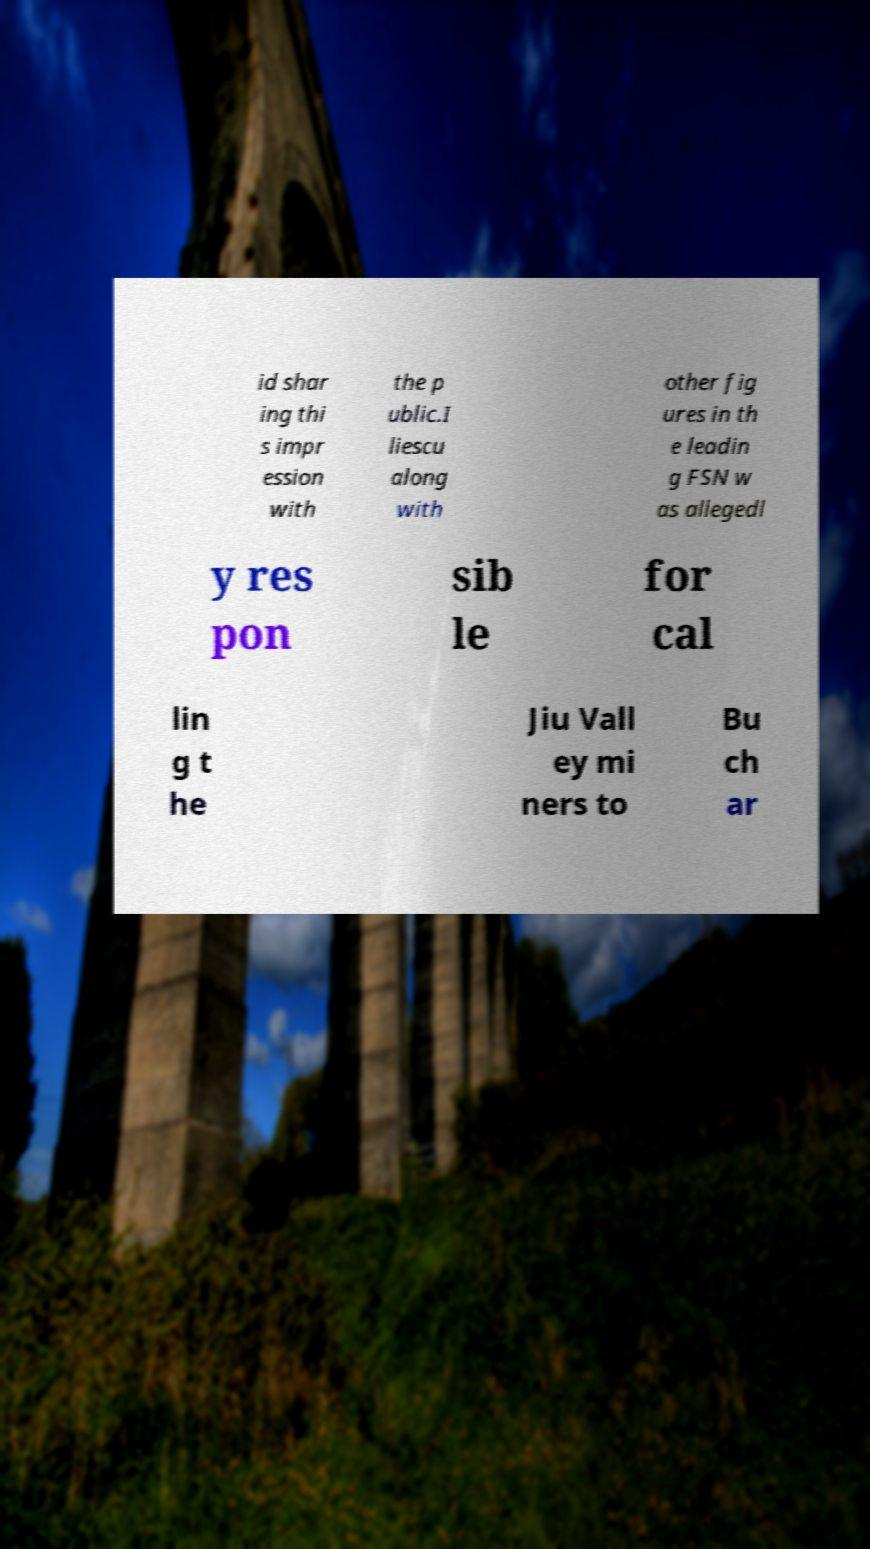Please read and relay the text visible in this image. What does it say? id shar ing thi s impr ession with the p ublic.I liescu along with other fig ures in th e leadin g FSN w as allegedl y res pon sib le for cal lin g t he Jiu Vall ey mi ners to Bu ch ar 